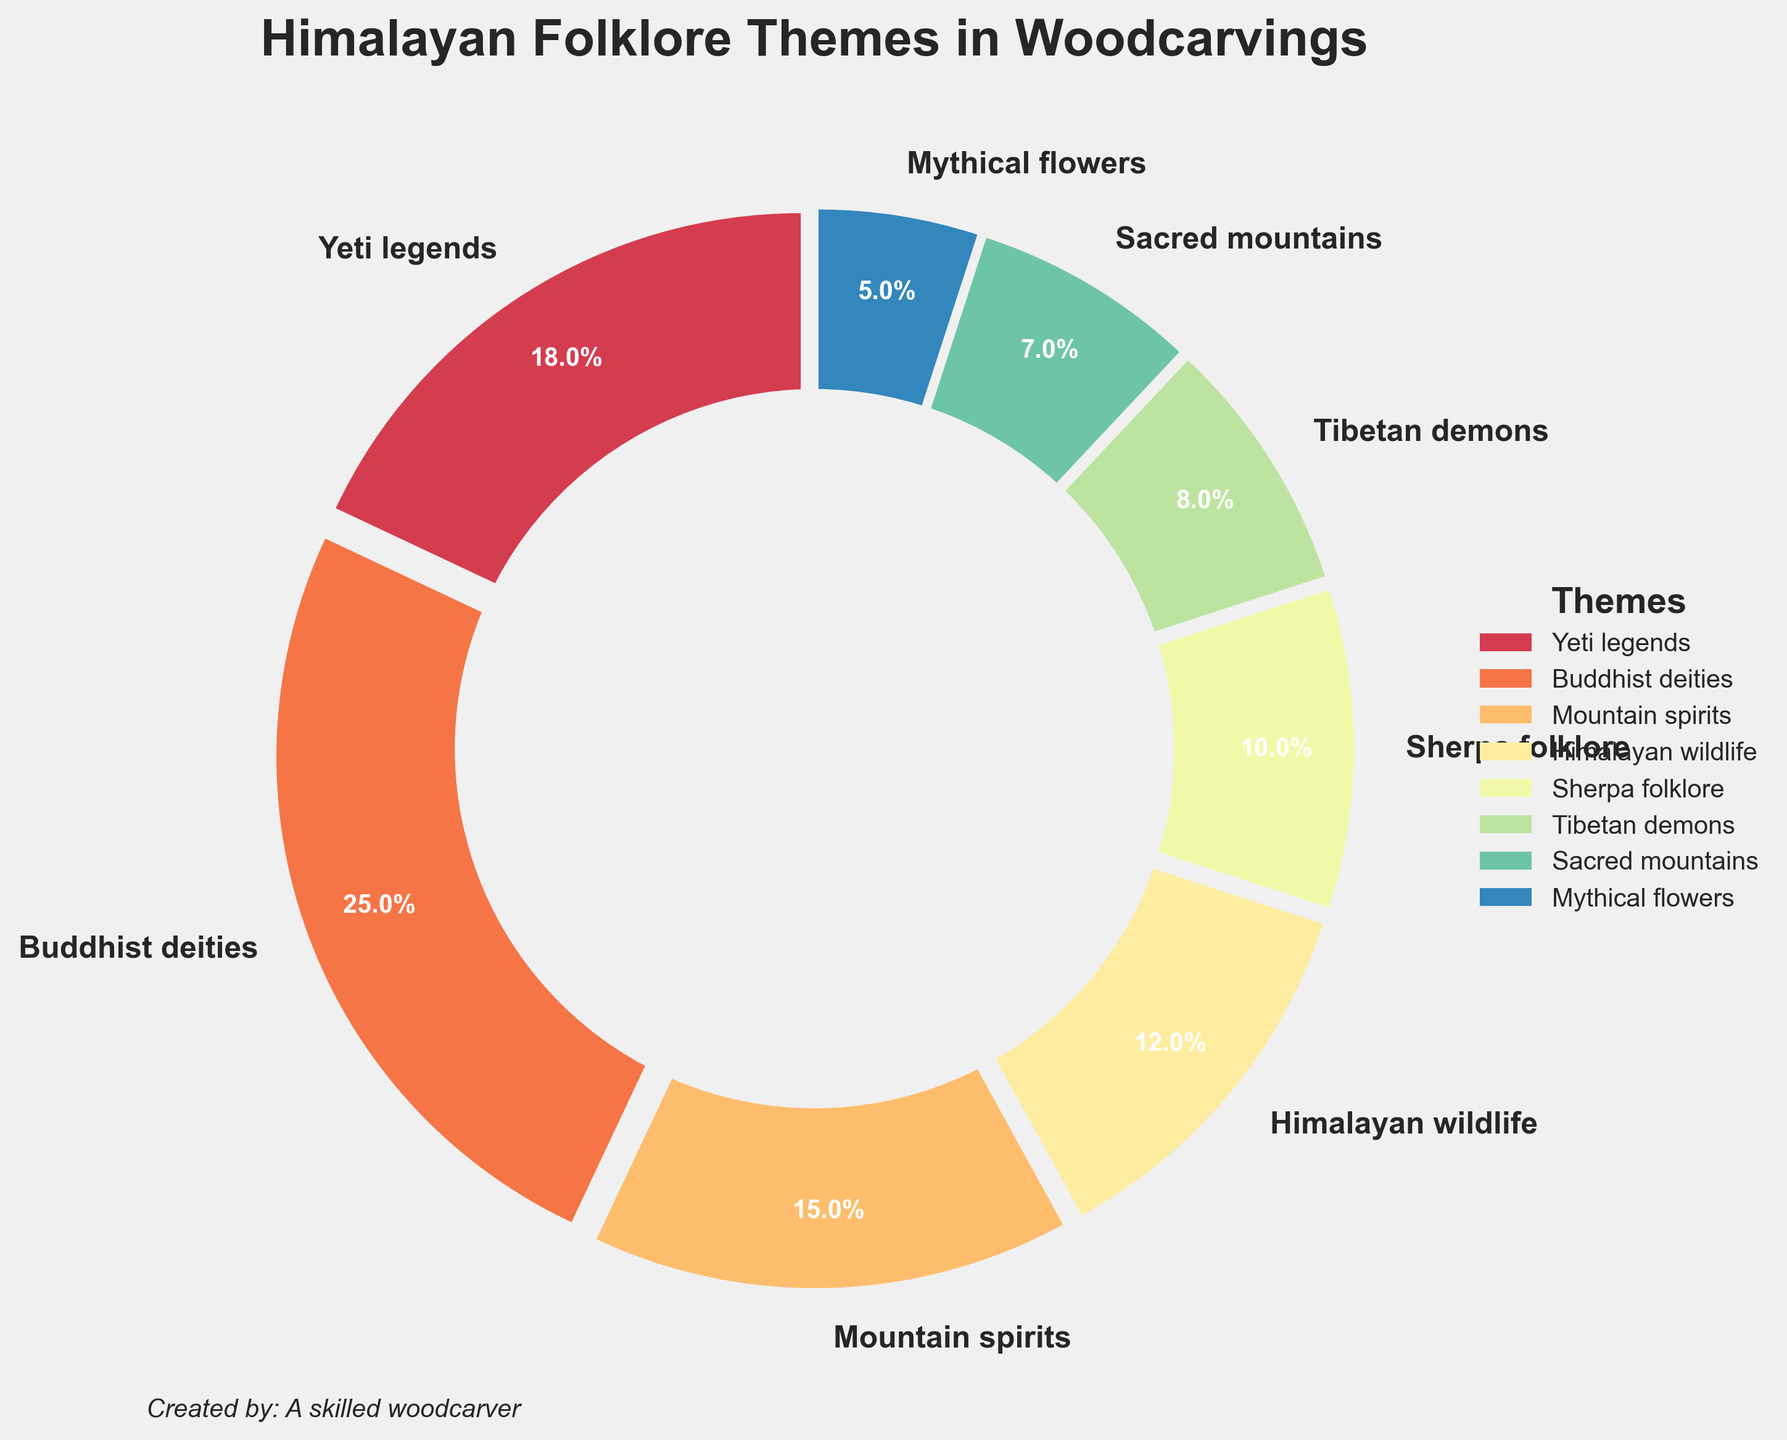What is the theme with the highest percentage? To find the theme with the highest percentage, look at the labels and percentages on the pie chart. Identify the highest numerical value.
Answer: Buddhist deities Which two themes have the least percentage, and what are their values? Search for the smallest slices in the pie chart and note their corresponding labels and percentages. The smallest ones should be easy to distinguish visually.
Answer: Sacred mountains (7%) and Mythical flowers (5%) What is the combined percentage of Yeti legends and Mountain spirits? Add the percentages of the Yeti legends (18%) and Mountain spirits (15%) together. 18% + 15% = 33%
Answer: 33% Which theme is more prominent, Sherpa folklore or Tibetan demons? Compare the numerical values of the percentages for Sherpa folklore (10%) and Tibetan demons (8%).
Answer: Sherpa folklore How much more percentage do Buddhist deities occupy compared to Himalayan wildlife? Subtract the percentage of Himalayan wildlife (12%) from Buddhist deities (25%). 25% - 12% = 13%
Answer: 13% Rank the themes in descending order of percentage. Review each percentage and order them from highest to lowest: 25% (Buddhist deities), 18% (Yeti legends), 15% (Mountain spirits), 12% (Himalayan wildlife), 10% (Sherpa folklore), 8% (Tibetan demons), 7% (Sacred mountains), 5% (Mythical flowers)
Answer: Buddhist deities, Yeti legends, Mountain spirits, Himalayan wildlife, Sherpa folklore, Tibetan demons, Sacred mountains, Mythical flowers How many themes are represented with a percentage of more than 10%? Count the number of themes that have a percentage greater than 10%: Buddhist deities (25%), Yeti legends (18%), Mountain spirits (15%), and Himalayan wildlife (12%).
Answer: 4 What is the average percentage of the themes: Tibetan demons, Sacred mountains, and Mythical flowers? Add the percentages of Tibetan demons (8%), Sacred mountains (7%), and Mythical flowers (5%) together and then divide by 3. (8% + 7% + 5%) / 3 = 6.67%
Answer: 6.67% Which theme has the smallest representation, and by how much is it smaller than the theme with the largest representation? Identify the smallest (Mythical flowers, 5%) and the largest (Buddhist deities, 25%) percentages and subtract the former from the latter. 25% - 5% = 20%
Answer: Mythical flowers, 20% 